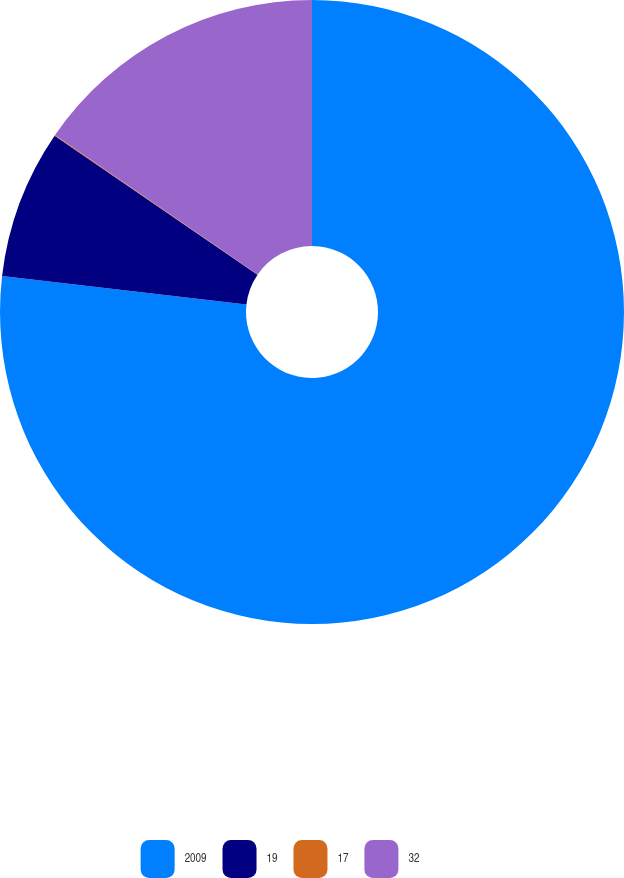Convert chart. <chart><loc_0><loc_0><loc_500><loc_500><pie_chart><fcel>2009<fcel>19<fcel>17<fcel>32<nl><fcel>76.84%<fcel>7.72%<fcel>0.04%<fcel>15.4%<nl></chart> 